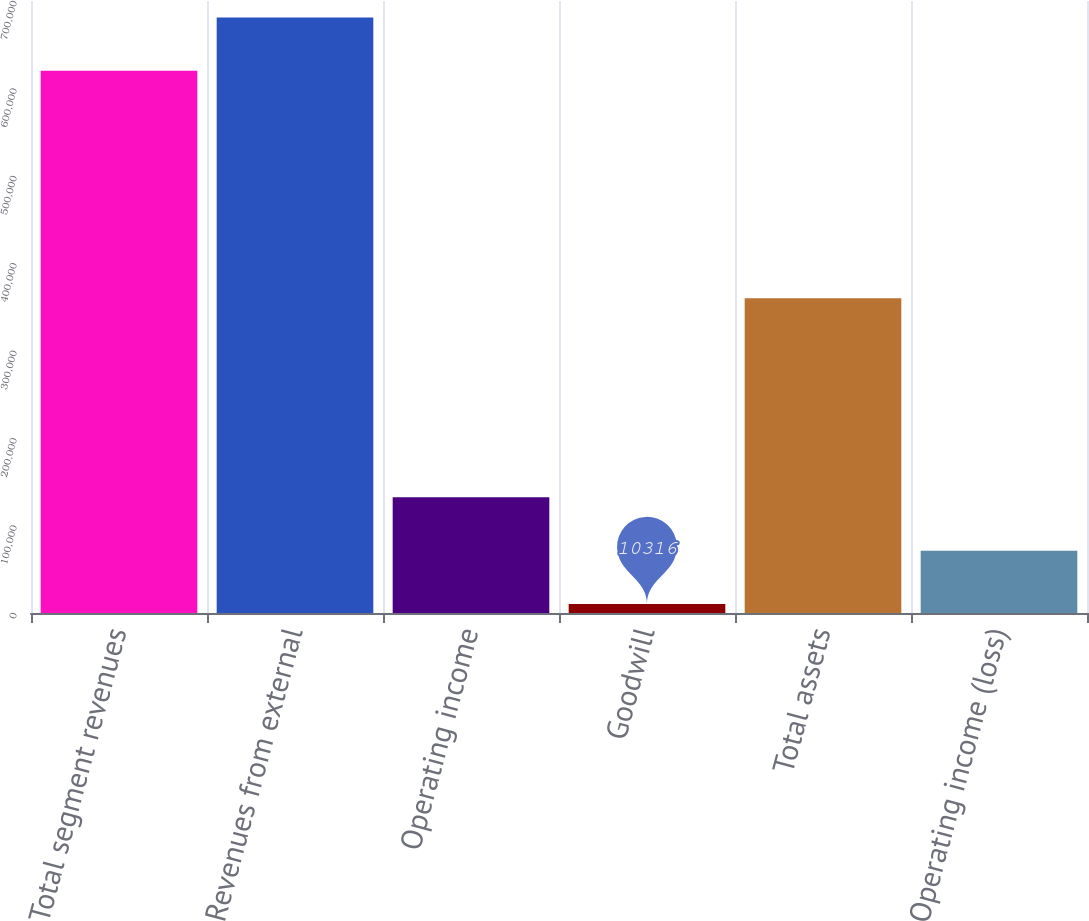Convert chart to OTSL. <chart><loc_0><loc_0><loc_500><loc_500><bar_chart><fcel>Total segment revenues<fcel>Revenues from external<fcel>Operating income<fcel>Goodwill<fcel>Total assets<fcel>Operating income (loss)<nl><fcel>620183<fcel>681170<fcel>132289<fcel>10316<fcel>359957<fcel>71302.7<nl></chart> 